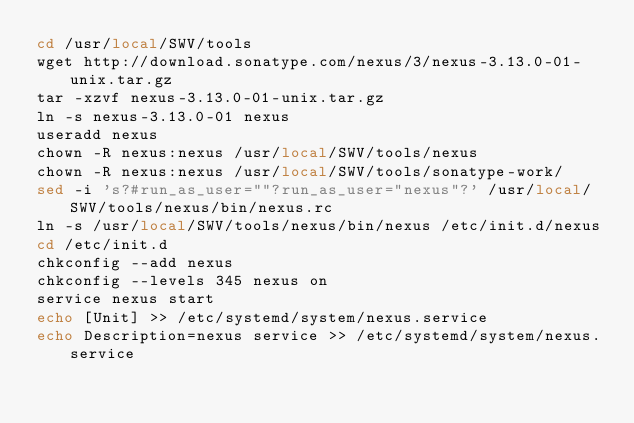<code> <loc_0><loc_0><loc_500><loc_500><_Bash_>cd /usr/local/SWV/tools
wget http://download.sonatype.com/nexus/3/nexus-3.13.0-01-unix.tar.gz
tar -xzvf nexus-3.13.0-01-unix.tar.gz
ln -s nexus-3.13.0-01 nexus
useradd nexus
chown -R nexus:nexus /usr/local/SWV/tools/nexus
chown -R nexus:nexus /usr/local/SWV/tools/sonatype-work/
sed -i 's?#run_as_user=""?run_as_user="nexus"?' /usr/local/SWV/tools/nexus/bin/nexus.rc
ln -s /usr/local/SWV/tools/nexus/bin/nexus /etc/init.d/nexus
cd /etc/init.d
chkconfig --add nexus
chkconfig --levels 345 nexus on
service nexus start
echo [Unit] >> /etc/systemd/system/nexus.service
echo Description=nexus service >> /etc/systemd/system/nexus.service</code> 